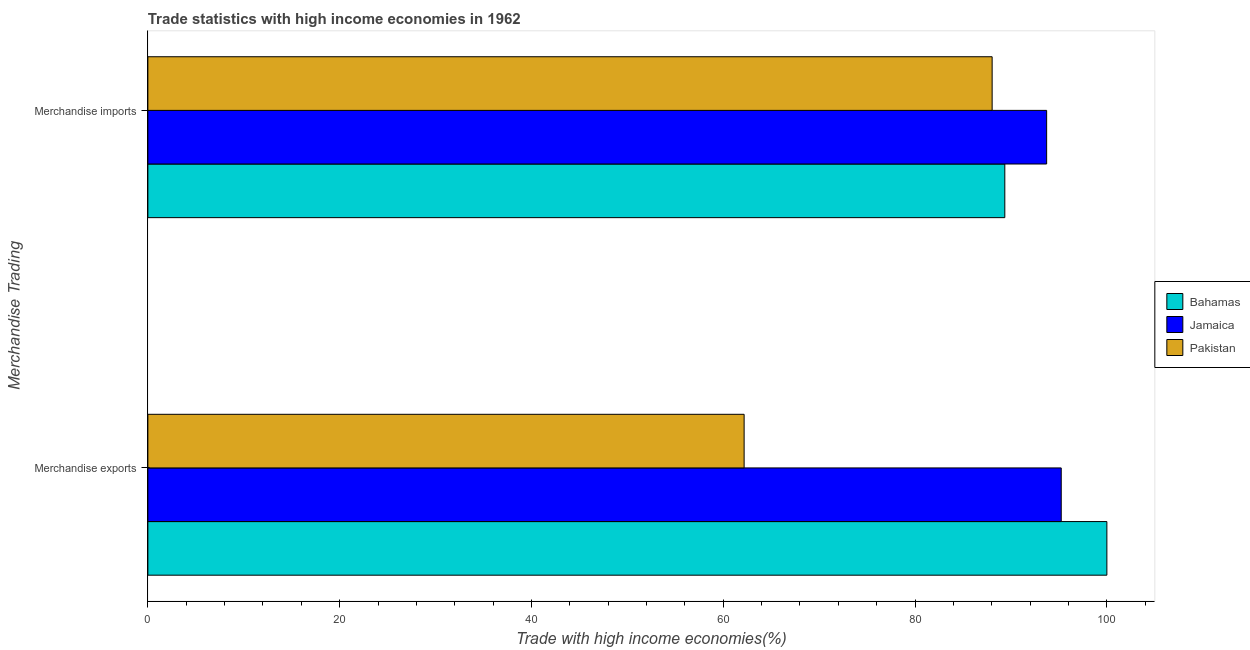How many different coloured bars are there?
Keep it short and to the point. 3. Are the number of bars per tick equal to the number of legend labels?
Give a very brief answer. Yes. Are the number of bars on each tick of the Y-axis equal?
Keep it short and to the point. Yes. How many bars are there on the 1st tick from the bottom?
Your response must be concise. 3. What is the label of the 2nd group of bars from the top?
Provide a short and direct response. Merchandise exports. What is the merchandise imports in Jamaica?
Offer a very short reply. 93.72. Across all countries, what is the minimum merchandise imports?
Your answer should be compact. 88.04. In which country was the merchandise exports maximum?
Provide a succinct answer. Bahamas. In which country was the merchandise exports minimum?
Make the answer very short. Pakistan. What is the total merchandise exports in the graph?
Make the answer very short. 257.42. What is the difference between the merchandise imports in Pakistan and that in Bahamas?
Keep it short and to the point. -1.32. What is the difference between the merchandise exports in Jamaica and the merchandise imports in Pakistan?
Make the answer very short. 7.2. What is the average merchandise exports per country?
Give a very brief answer. 85.81. What is the difference between the merchandise imports and merchandise exports in Jamaica?
Ensure brevity in your answer.  -1.52. In how many countries, is the merchandise imports greater than 16 %?
Your answer should be very brief. 3. What is the ratio of the merchandise exports in Pakistan to that in Jamaica?
Provide a succinct answer. 0.65. What does the 1st bar from the top in Merchandise imports represents?
Offer a terse response. Pakistan. What does the 2nd bar from the bottom in Merchandise imports represents?
Your response must be concise. Jamaica. Are all the bars in the graph horizontal?
Make the answer very short. Yes. How many countries are there in the graph?
Offer a very short reply. 3. What is the difference between two consecutive major ticks on the X-axis?
Give a very brief answer. 20. Are the values on the major ticks of X-axis written in scientific E-notation?
Your answer should be compact. No. Where does the legend appear in the graph?
Provide a short and direct response. Center right. How many legend labels are there?
Provide a short and direct response. 3. What is the title of the graph?
Provide a succinct answer. Trade statistics with high income economies in 1962. Does "Bahamas" appear as one of the legend labels in the graph?
Provide a short and direct response. Yes. What is the label or title of the X-axis?
Ensure brevity in your answer.  Trade with high income economies(%). What is the label or title of the Y-axis?
Offer a terse response. Merchandise Trading. What is the Trade with high income economies(%) in Jamaica in Merchandise exports?
Give a very brief answer. 95.24. What is the Trade with high income economies(%) of Pakistan in Merchandise exports?
Make the answer very short. 62.17. What is the Trade with high income economies(%) in Bahamas in Merchandise imports?
Offer a very short reply. 89.36. What is the Trade with high income economies(%) in Jamaica in Merchandise imports?
Make the answer very short. 93.72. What is the Trade with high income economies(%) in Pakistan in Merchandise imports?
Your response must be concise. 88.04. Across all Merchandise Trading, what is the maximum Trade with high income economies(%) in Jamaica?
Make the answer very short. 95.24. Across all Merchandise Trading, what is the maximum Trade with high income economies(%) in Pakistan?
Ensure brevity in your answer.  88.04. Across all Merchandise Trading, what is the minimum Trade with high income economies(%) of Bahamas?
Offer a very short reply. 89.36. Across all Merchandise Trading, what is the minimum Trade with high income economies(%) in Jamaica?
Make the answer very short. 93.72. Across all Merchandise Trading, what is the minimum Trade with high income economies(%) in Pakistan?
Give a very brief answer. 62.17. What is the total Trade with high income economies(%) of Bahamas in the graph?
Your answer should be compact. 189.36. What is the total Trade with high income economies(%) in Jamaica in the graph?
Give a very brief answer. 188.96. What is the total Trade with high income economies(%) of Pakistan in the graph?
Provide a succinct answer. 150.21. What is the difference between the Trade with high income economies(%) in Bahamas in Merchandise exports and that in Merchandise imports?
Keep it short and to the point. 10.64. What is the difference between the Trade with high income economies(%) in Jamaica in Merchandise exports and that in Merchandise imports?
Your answer should be very brief. 1.52. What is the difference between the Trade with high income economies(%) in Pakistan in Merchandise exports and that in Merchandise imports?
Give a very brief answer. -25.86. What is the difference between the Trade with high income economies(%) of Bahamas in Merchandise exports and the Trade with high income economies(%) of Jamaica in Merchandise imports?
Your response must be concise. 6.28. What is the difference between the Trade with high income economies(%) in Bahamas in Merchandise exports and the Trade with high income economies(%) in Pakistan in Merchandise imports?
Offer a terse response. 11.96. What is the difference between the Trade with high income economies(%) in Jamaica in Merchandise exports and the Trade with high income economies(%) in Pakistan in Merchandise imports?
Your response must be concise. 7.2. What is the average Trade with high income economies(%) in Bahamas per Merchandise Trading?
Make the answer very short. 94.68. What is the average Trade with high income economies(%) of Jamaica per Merchandise Trading?
Ensure brevity in your answer.  94.48. What is the average Trade with high income economies(%) in Pakistan per Merchandise Trading?
Your answer should be very brief. 75.11. What is the difference between the Trade with high income economies(%) in Bahamas and Trade with high income economies(%) in Jamaica in Merchandise exports?
Offer a very short reply. 4.76. What is the difference between the Trade with high income economies(%) in Bahamas and Trade with high income economies(%) in Pakistan in Merchandise exports?
Make the answer very short. 37.83. What is the difference between the Trade with high income economies(%) in Jamaica and Trade with high income economies(%) in Pakistan in Merchandise exports?
Your answer should be compact. 33.07. What is the difference between the Trade with high income economies(%) of Bahamas and Trade with high income economies(%) of Jamaica in Merchandise imports?
Offer a terse response. -4.36. What is the difference between the Trade with high income economies(%) in Bahamas and Trade with high income economies(%) in Pakistan in Merchandise imports?
Provide a succinct answer. 1.32. What is the difference between the Trade with high income economies(%) of Jamaica and Trade with high income economies(%) of Pakistan in Merchandise imports?
Your response must be concise. 5.68. What is the ratio of the Trade with high income economies(%) in Bahamas in Merchandise exports to that in Merchandise imports?
Keep it short and to the point. 1.12. What is the ratio of the Trade with high income economies(%) of Jamaica in Merchandise exports to that in Merchandise imports?
Provide a succinct answer. 1.02. What is the ratio of the Trade with high income economies(%) in Pakistan in Merchandise exports to that in Merchandise imports?
Offer a very short reply. 0.71. What is the difference between the highest and the second highest Trade with high income economies(%) of Bahamas?
Ensure brevity in your answer.  10.64. What is the difference between the highest and the second highest Trade with high income economies(%) in Jamaica?
Make the answer very short. 1.52. What is the difference between the highest and the second highest Trade with high income economies(%) in Pakistan?
Your answer should be compact. 25.86. What is the difference between the highest and the lowest Trade with high income economies(%) in Bahamas?
Ensure brevity in your answer.  10.64. What is the difference between the highest and the lowest Trade with high income economies(%) in Jamaica?
Give a very brief answer. 1.52. What is the difference between the highest and the lowest Trade with high income economies(%) in Pakistan?
Keep it short and to the point. 25.86. 